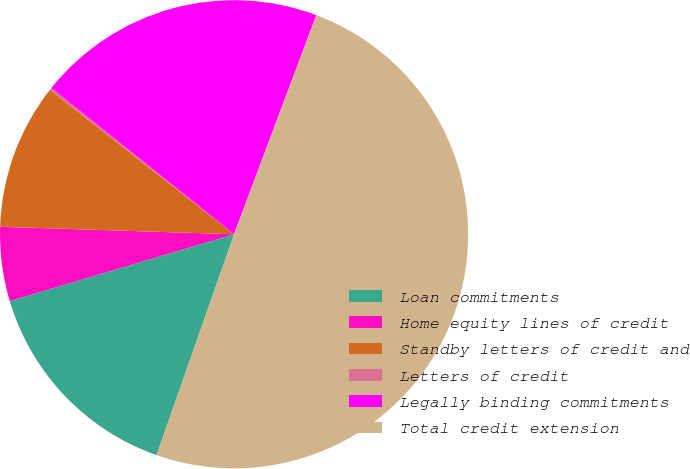Convert chart. <chart><loc_0><loc_0><loc_500><loc_500><pie_chart><fcel>Loan commitments<fcel>Home equity lines of credit<fcel>Standby letters of credit and<fcel>Letters of credit<fcel>Legally binding commitments<fcel>Total credit extension<nl><fcel>15.02%<fcel>5.12%<fcel>10.07%<fcel>0.17%<fcel>19.97%<fcel>49.66%<nl></chart> 